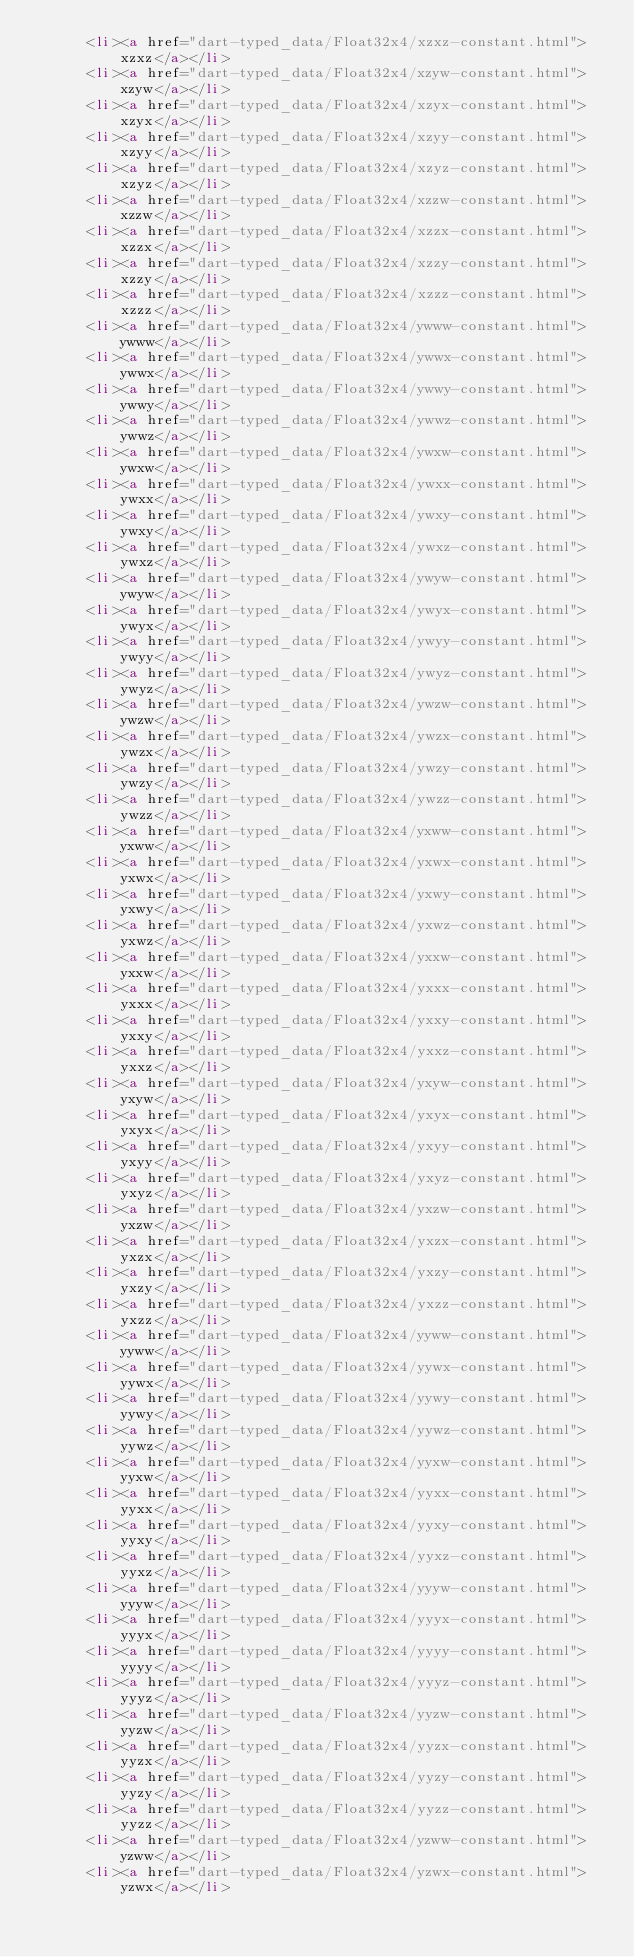Convert code to text. <code><loc_0><loc_0><loc_500><loc_500><_HTML_>      <li><a href="dart-typed_data/Float32x4/xzxz-constant.html">xzxz</a></li>
      <li><a href="dart-typed_data/Float32x4/xzyw-constant.html">xzyw</a></li>
      <li><a href="dart-typed_data/Float32x4/xzyx-constant.html">xzyx</a></li>
      <li><a href="dart-typed_data/Float32x4/xzyy-constant.html">xzyy</a></li>
      <li><a href="dart-typed_data/Float32x4/xzyz-constant.html">xzyz</a></li>
      <li><a href="dart-typed_data/Float32x4/xzzw-constant.html">xzzw</a></li>
      <li><a href="dart-typed_data/Float32x4/xzzx-constant.html">xzzx</a></li>
      <li><a href="dart-typed_data/Float32x4/xzzy-constant.html">xzzy</a></li>
      <li><a href="dart-typed_data/Float32x4/xzzz-constant.html">xzzz</a></li>
      <li><a href="dart-typed_data/Float32x4/ywww-constant.html">ywww</a></li>
      <li><a href="dart-typed_data/Float32x4/ywwx-constant.html">ywwx</a></li>
      <li><a href="dart-typed_data/Float32x4/ywwy-constant.html">ywwy</a></li>
      <li><a href="dart-typed_data/Float32x4/ywwz-constant.html">ywwz</a></li>
      <li><a href="dart-typed_data/Float32x4/ywxw-constant.html">ywxw</a></li>
      <li><a href="dart-typed_data/Float32x4/ywxx-constant.html">ywxx</a></li>
      <li><a href="dart-typed_data/Float32x4/ywxy-constant.html">ywxy</a></li>
      <li><a href="dart-typed_data/Float32x4/ywxz-constant.html">ywxz</a></li>
      <li><a href="dart-typed_data/Float32x4/ywyw-constant.html">ywyw</a></li>
      <li><a href="dart-typed_data/Float32x4/ywyx-constant.html">ywyx</a></li>
      <li><a href="dart-typed_data/Float32x4/ywyy-constant.html">ywyy</a></li>
      <li><a href="dart-typed_data/Float32x4/ywyz-constant.html">ywyz</a></li>
      <li><a href="dart-typed_data/Float32x4/ywzw-constant.html">ywzw</a></li>
      <li><a href="dart-typed_data/Float32x4/ywzx-constant.html">ywzx</a></li>
      <li><a href="dart-typed_data/Float32x4/ywzy-constant.html">ywzy</a></li>
      <li><a href="dart-typed_data/Float32x4/ywzz-constant.html">ywzz</a></li>
      <li><a href="dart-typed_data/Float32x4/yxww-constant.html">yxww</a></li>
      <li><a href="dart-typed_data/Float32x4/yxwx-constant.html">yxwx</a></li>
      <li><a href="dart-typed_data/Float32x4/yxwy-constant.html">yxwy</a></li>
      <li><a href="dart-typed_data/Float32x4/yxwz-constant.html">yxwz</a></li>
      <li><a href="dart-typed_data/Float32x4/yxxw-constant.html">yxxw</a></li>
      <li><a href="dart-typed_data/Float32x4/yxxx-constant.html">yxxx</a></li>
      <li><a href="dart-typed_data/Float32x4/yxxy-constant.html">yxxy</a></li>
      <li><a href="dart-typed_data/Float32x4/yxxz-constant.html">yxxz</a></li>
      <li><a href="dart-typed_data/Float32x4/yxyw-constant.html">yxyw</a></li>
      <li><a href="dart-typed_data/Float32x4/yxyx-constant.html">yxyx</a></li>
      <li><a href="dart-typed_data/Float32x4/yxyy-constant.html">yxyy</a></li>
      <li><a href="dart-typed_data/Float32x4/yxyz-constant.html">yxyz</a></li>
      <li><a href="dart-typed_data/Float32x4/yxzw-constant.html">yxzw</a></li>
      <li><a href="dart-typed_data/Float32x4/yxzx-constant.html">yxzx</a></li>
      <li><a href="dart-typed_data/Float32x4/yxzy-constant.html">yxzy</a></li>
      <li><a href="dart-typed_data/Float32x4/yxzz-constant.html">yxzz</a></li>
      <li><a href="dart-typed_data/Float32x4/yyww-constant.html">yyww</a></li>
      <li><a href="dart-typed_data/Float32x4/yywx-constant.html">yywx</a></li>
      <li><a href="dart-typed_data/Float32x4/yywy-constant.html">yywy</a></li>
      <li><a href="dart-typed_data/Float32x4/yywz-constant.html">yywz</a></li>
      <li><a href="dart-typed_data/Float32x4/yyxw-constant.html">yyxw</a></li>
      <li><a href="dart-typed_data/Float32x4/yyxx-constant.html">yyxx</a></li>
      <li><a href="dart-typed_data/Float32x4/yyxy-constant.html">yyxy</a></li>
      <li><a href="dart-typed_data/Float32x4/yyxz-constant.html">yyxz</a></li>
      <li><a href="dart-typed_data/Float32x4/yyyw-constant.html">yyyw</a></li>
      <li><a href="dart-typed_data/Float32x4/yyyx-constant.html">yyyx</a></li>
      <li><a href="dart-typed_data/Float32x4/yyyy-constant.html">yyyy</a></li>
      <li><a href="dart-typed_data/Float32x4/yyyz-constant.html">yyyz</a></li>
      <li><a href="dart-typed_data/Float32x4/yyzw-constant.html">yyzw</a></li>
      <li><a href="dart-typed_data/Float32x4/yyzx-constant.html">yyzx</a></li>
      <li><a href="dart-typed_data/Float32x4/yyzy-constant.html">yyzy</a></li>
      <li><a href="dart-typed_data/Float32x4/yyzz-constant.html">yyzz</a></li>
      <li><a href="dart-typed_data/Float32x4/yzww-constant.html">yzww</a></li>
      <li><a href="dart-typed_data/Float32x4/yzwx-constant.html">yzwx</a></li></code> 